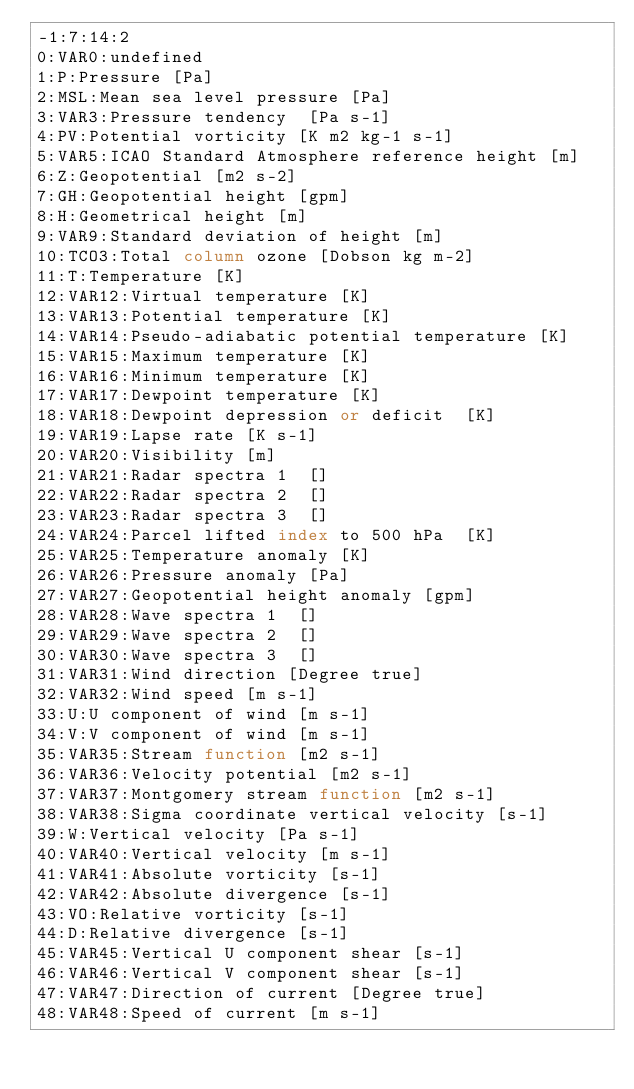<code> <loc_0><loc_0><loc_500><loc_500><_SQL_>-1:7:14:2
0:VAR0:undefined
1:P:Pressure [Pa]
2:MSL:Mean sea level pressure [Pa]
3:VAR3:Pressure tendency  [Pa s-1]
4:PV:Potential vorticity [K m2 kg-1 s-1]
5:VAR5:ICAO Standard Atmosphere reference height [m]
6:Z:Geopotential [m2 s-2]
7:GH:Geopotential height [gpm]
8:H:Geometrical height [m]
9:VAR9:Standard deviation of height [m]
10:TCO3:Total column ozone [Dobson kg m-2]
11:T:Temperature [K]
12:VAR12:Virtual temperature [K]
13:VAR13:Potential temperature [K]
14:VAR14:Pseudo-adiabatic potential temperature [K]
15:VAR15:Maximum temperature [K]
16:VAR16:Minimum temperature [K]
17:VAR17:Dewpoint temperature [K]
18:VAR18:Dewpoint depression or deficit  [K]
19:VAR19:Lapse rate [K s-1]
20:VAR20:Visibility [m]
21:VAR21:Radar spectra 1  []
22:VAR22:Radar spectra 2  []
23:VAR23:Radar spectra 3  []
24:VAR24:Parcel lifted index to 500 hPa  [K]
25:VAR25:Temperature anomaly [K]
26:VAR26:Pressure anomaly [Pa]
27:VAR27:Geopotential height anomaly [gpm]
28:VAR28:Wave spectra 1  []
29:VAR29:Wave spectra 2  []
30:VAR30:Wave spectra 3  []
31:VAR31:Wind direction [Degree true]
32:VAR32:Wind speed [m s-1]
33:U:U component of wind [m s-1]
34:V:V component of wind [m s-1]
35:VAR35:Stream function [m2 s-1]
36:VAR36:Velocity potential [m2 s-1]
37:VAR37:Montgomery stream function [m2 s-1]
38:VAR38:Sigma coordinate vertical velocity [s-1]
39:W:Vertical velocity [Pa s-1]
40:VAR40:Vertical velocity [m s-1]
41:VAR41:Absolute vorticity [s-1]
42:VAR42:Absolute divergence [s-1]
43:VO:Relative vorticity [s-1]
44:D:Relative divergence [s-1]
45:VAR45:Vertical U component shear [s-1]
46:VAR46:Vertical V component shear [s-1]
47:VAR47:Direction of current [Degree true]
48:VAR48:Speed of current [m s-1]</code> 